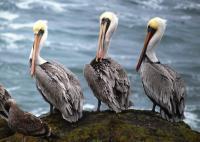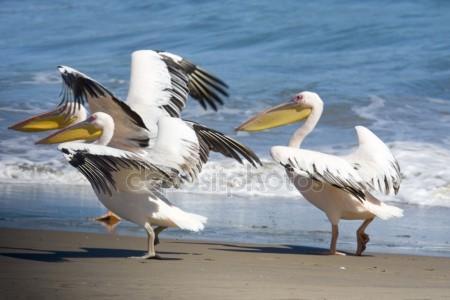The first image is the image on the left, the second image is the image on the right. Given the left and right images, does the statement "In one of the image there is a pelican in the water." hold true? Answer yes or no. No. The first image is the image on the left, the second image is the image on the right. Evaluate the accuracy of this statement regarding the images: "At least 6 pelicans face left.". Is it true? Answer yes or no. Yes. 